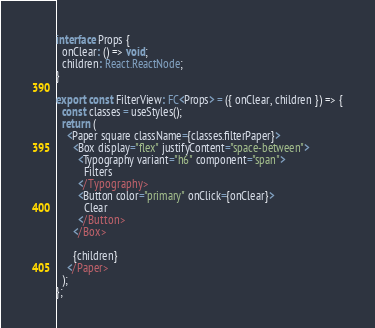<code> <loc_0><loc_0><loc_500><loc_500><_TypeScript_>
interface Props {
  onClear: () => void;
  children: React.ReactNode;
}

export const FilterView: FC<Props> = ({ onClear, children }) => {
  const classes = useStyles();
  return (
    <Paper square className={classes.filterPaper}>
      <Box display="flex" justifyContent="space-between">
        <Typography variant="h6" component="span">
          Filters
        </Typography>
        <Button color="primary" onClick={onClear}>
          Clear
        </Button>
      </Box>

      {children}
    </Paper>
  );
};
</code> 